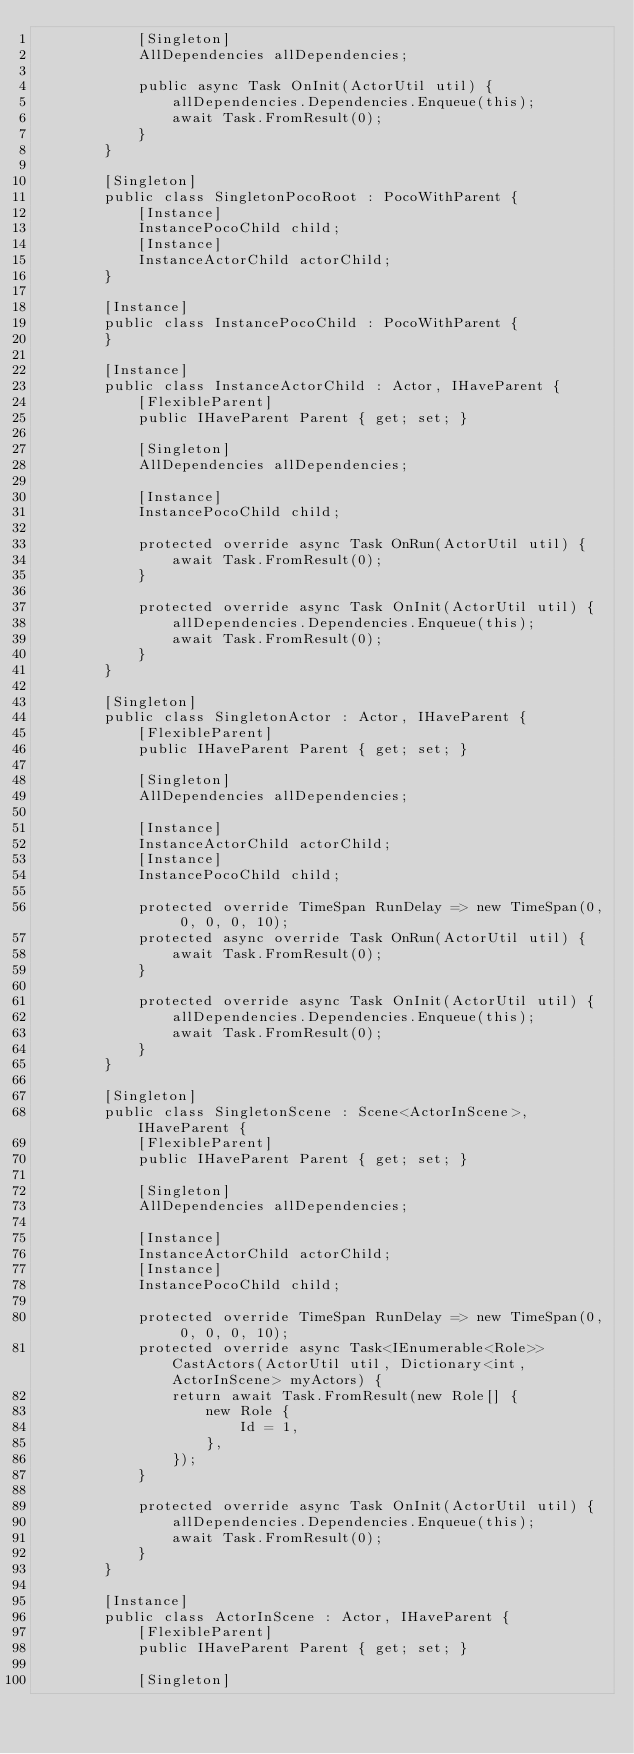<code> <loc_0><loc_0><loc_500><loc_500><_C#_>            [Singleton]
            AllDependencies allDependencies;

            public async Task OnInit(ActorUtil util) {
                allDependencies.Dependencies.Enqueue(this);
                await Task.FromResult(0);
            }
        }

        [Singleton]
        public class SingletonPocoRoot : PocoWithParent {
            [Instance]
            InstancePocoChild child;
            [Instance]
            InstanceActorChild actorChild;
        }

        [Instance]
        public class InstancePocoChild : PocoWithParent {
        }

        [Instance]
        public class InstanceActorChild : Actor, IHaveParent {
            [FlexibleParent]
            public IHaveParent Parent { get; set; }

            [Singleton]
            AllDependencies allDependencies;

            [Instance]
            InstancePocoChild child;

            protected override async Task OnRun(ActorUtil util) {
                await Task.FromResult(0);
            }

            protected override async Task OnInit(ActorUtil util) {
                allDependencies.Dependencies.Enqueue(this);
                await Task.FromResult(0);
            }
        }

        [Singleton]
        public class SingletonActor : Actor, IHaveParent {
            [FlexibleParent]
            public IHaveParent Parent { get; set; }

            [Singleton]
            AllDependencies allDependencies;

            [Instance]
            InstanceActorChild actorChild;
            [Instance]
            InstancePocoChild child;

            protected override TimeSpan RunDelay => new TimeSpan(0, 0, 0, 0, 10);
            protected async override Task OnRun(ActorUtil util) {
                await Task.FromResult(0);
            }

            protected override async Task OnInit(ActorUtil util) {
                allDependencies.Dependencies.Enqueue(this);
                await Task.FromResult(0);
            }
        }

        [Singleton]
        public class SingletonScene : Scene<ActorInScene>, IHaveParent {
            [FlexibleParent]
            public IHaveParent Parent { get; set; }

            [Singleton]
            AllDependencies allDependencies;

            [Instance]
            InstanceActorChild actorChild;
            [Instance]
            InstancePocoChild child;

            protected override TimeSpan RunDelay => new TimeSpan(0, 0, 0, 0, 10);
            protected override async Task<IEnumerable<Role>> CastActors(ActorUtil util, Dictionary<int, ActorInScene> myActors) {
                return await Task.FromResult(new Role[] {
                    new Role {
                        Id = 1,
                    },
                });
            }

            protected override async Task OnInit(ActorUtil util) {
                allDependencies.Dependencies.Enqueue(this);
                await Task.FromResult(0);
            }
        }

        [Instance]
        public class ActorInScene : Actor, IHaveParent {
            [FlexibleParent]
            public IHaveParent Parent { get; set; }

            [Singleton]</code> 